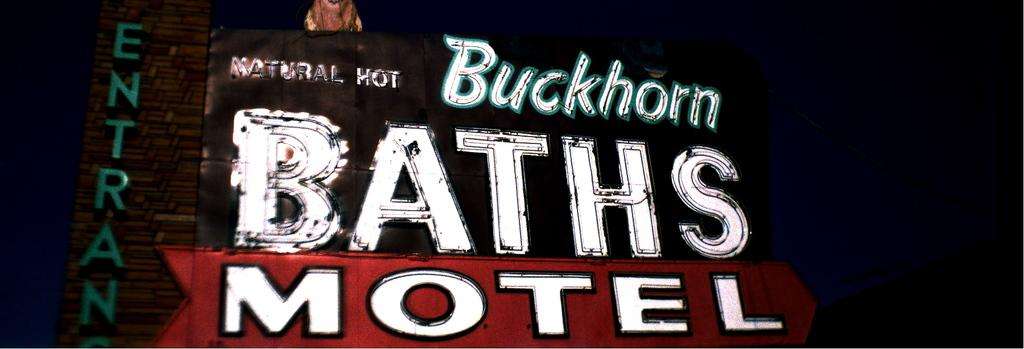Provide a one-sentence caption for the provided image. A neon sign for Buckhorn Baths and Motel. 